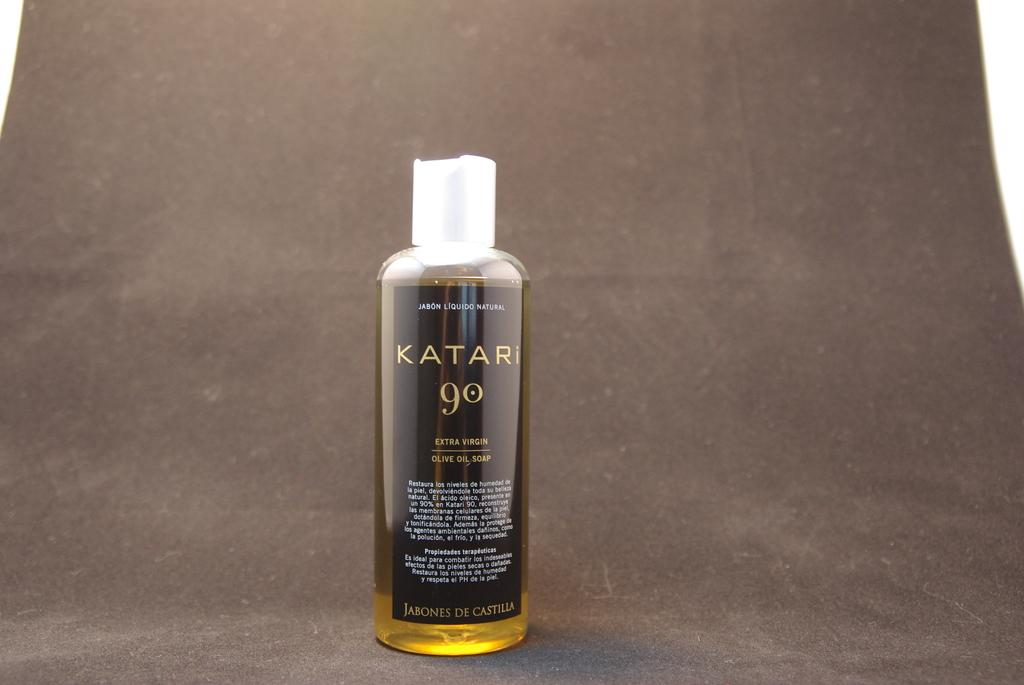Provide a one-sentence caption for the provided image. A bottle of extra virgin olive oil soap is displayed on a grey background. 